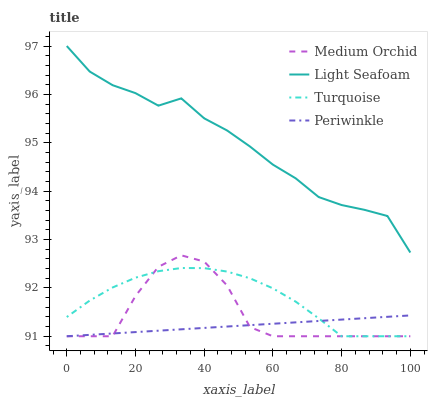Does Periwinkle have the minimum area under the curve?
Answer yes or no. Yes. Does Light Seafoam have the maximum area under the curve?
Answer yes or no. Yes. Does Medium Orchid have the minimum area under the curve?
Answer yes or no. No. Does Medium Orchid have the maximum area under the curve?
Answer yes or no. No. Is Periwinkle the smoothest?
Answer yes or no. Yes. Is Medium Orchid the roughest?
Answer yes or no. Yes. Is Medium Orchid the smoothest?
Answer yes or no. No. Is Periwinkle the roughest?
Answer yes or no. No. Does Light Seafoam have the lowest value?
Answer yes or no. No. Does Light Seafoam have the highest value?
Answer yes or no. Yes. Does Medium Orchid have the highest value?
Answer yes or no. No. Is Medium Orchid less than Light Seafoam?
Answer yes or no. Yes. Is Light Seafoam greater than Medium Orchid?
Answer yes or no. Yes. Does Turquoise intersect Medium Orchid?
Answer yes or no. Yes. Is Turquoise less than Medium Orchid?
Answer yes or no. No. Is Turquoise greater than Medium Orchid?
Answer yes or no. No. Does Medium Orchid intersect Light Seafoam?
Answer yes or no. No. 